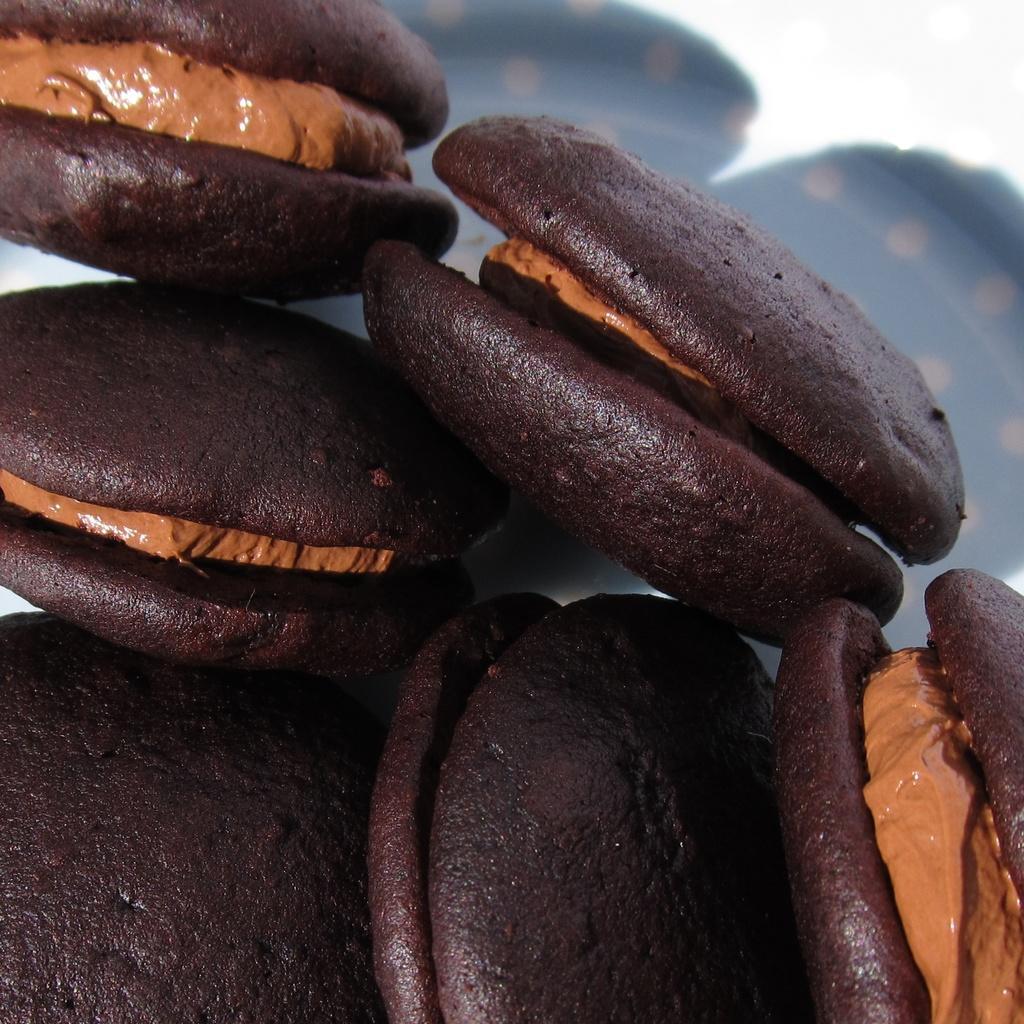Could you give a brief overview of what you see in this image? In this image we can see a food item which looks like cookies. 